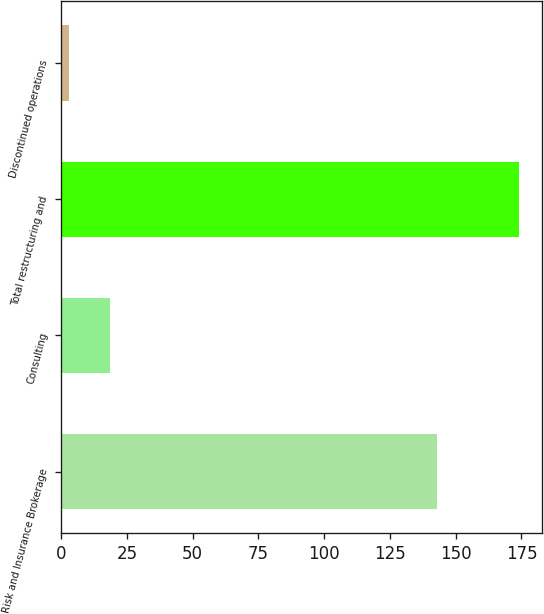<chart> <loc_0><loc_0><loc_500><loc_500><bar_chart><fcel>Risk and Insurance Brokerage<fcel>Consulting<fcel>Total restructuring and<fcel>Discontinued operations<nl><fcel>143<fcel>18.5<fcel>174<fcel>3<nl></chart> 